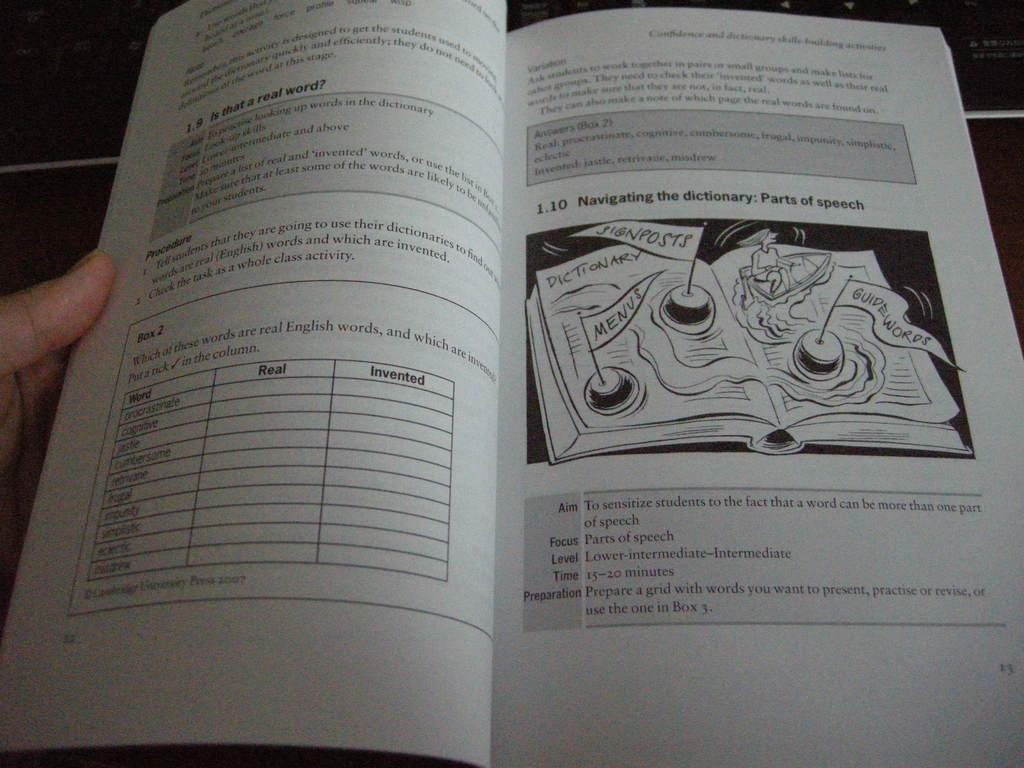What object is present in the image that is typically used for reading? There is a book in the image. What can be seen on the book's cover or pages? There is writing and an image on the book. Can you describe the fingers visible on the left side of the image? The fingers of a person are visible on the left side of the image. What type of ball is being held by the person in the image? There is no ball present in the image; only a book and fingers are visible. Can you describe the rose that is being smelled by the person in the image? There is no rose present in the image; only a book and fingers are visible. 